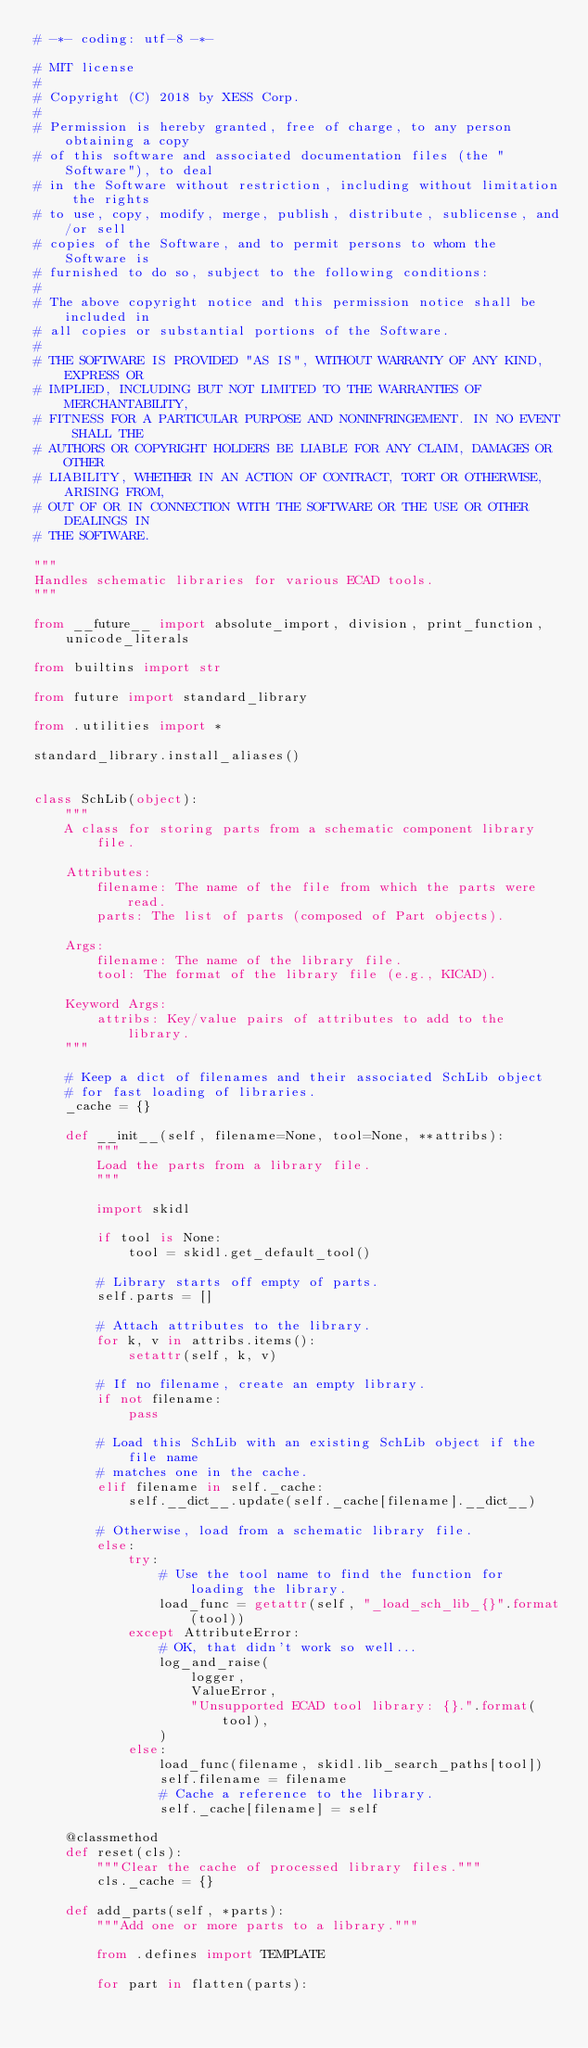<code> <loc_0><loc_0><loc_500><loc_500><_Python_># -*- coding: utf-8 -*-

# MIT license
#
# Copyright (C) 2018 by XESS Corp.
#
# Permission is hereby granted, free of charge, to any person obtaining a copy
# of this software and associated documentation files (the "Software"), to deal
# in the Software without restriction, including without limitation the rights
# to use, copy, modify, merge, publish, distribute, sublicense, and/or sell
# copies of the Software, and to permit persons to whom the Software is
# furnished to do so, subject to the following conditions:
#
# The above copyright notice and this permission notice shall be included in
# all copies or substantial portions of the Software.
#
# THE SOFTWARE IS PROVIDED "AS IS", WITHOUT WARRANTY OF ANY KIND, EXPRESS OR
# IMPLIED, INCLUDING BUT NOT LIMITED TO THE WARRANTIES OF MERCHANTABILITY,
# FITNESS FOR A PARTICULAR PURPOSE AND NONINFRINGEMENT. IN NO EVENT SHALL THE
# AUTHORS OR COPYRIGHT HOLDERS BE LIABLE FOR ANY CLAIM, DAMAGES OR OTHER
# LIABILITY, WHETHER IN AN ACTION OF CONTRACT, TORT OR OTHERWISE, ARISING FROM,
# OUT OF OR IN CONNECTION WITH THE SOFTWARE OR THE USE OR OTHER DEALINGS IN
# THE SOFTWARE.

"""
Handles schematic libraries for various ECAD tools.
"""

from __future__ import absolute_import, division, print_function, unicode_literals

from builtins import str

from future import standard_library

from .utilities import *

standard_library.install_aliases()


class SchLib(object):
    """
    A class for storing parts from a schematic component library file.

    Attributes:
        filename: The name of the file from which the parts were read.
        parts: The list of parts (composed of Part objects).

    Args:
        filename: The name of the library file.
        tool: The format of the library file (e.g., KICAD).

    Keyword Args:
        attribs: Key/value pairs of attributes to add to the library.
    """

    # Keep a dict of filenames and their associated SchLib object
    # for fast loading of libraries.
    _cache = {}

    def __init__(self, filename=None, tool=None, **attribs):
        """
        Load the parts from a library file.
        """

        import skidl

        if tool is None:
            tool = skidl.get_default_tool()

        # Library starts off empty of parts.
        self.parts = []

        # Attach attributes to the library.
        for k, v in attribs.items():
            setattr(self, k, v)

        # If no filename, create an empty library.
        if not filename:
            pass

        # Load this SchLib with an existing SchLib object if the file name
        # matches one in the cache.
        elif filename in self._cache:
            self.__dict__.update(self._cache[filename].__dict__)

        # Otherwise, load from a schematic library file.
        else:
            try:
                # Use the tool name to find the function for loading the library.
                load_func = getattr(self, "_load_sch_lib_{}".format(tool))
            except AttributeError:
                # OK, that didn't work so well...
                log_and_raise(
                    logger,
                    ValueError,
                    "Unsupported ECAD tool library: {}.".format(tool),
                )
            else:
                load_func(filename, skidl.lib_search_paths[tool])
                self.filename = filename
                # Cache a reference to the library.
                self._cache[filename] = self

    @classmethod
    def reset(cls):
        """Clear the cache of processed library files."""
        cls._cache = {}

    def add_parts(self, *parts):
        """Add one or more parts to a library."""

        from .defines import TEMPLATE

        for part in flatten(parts):</code> 